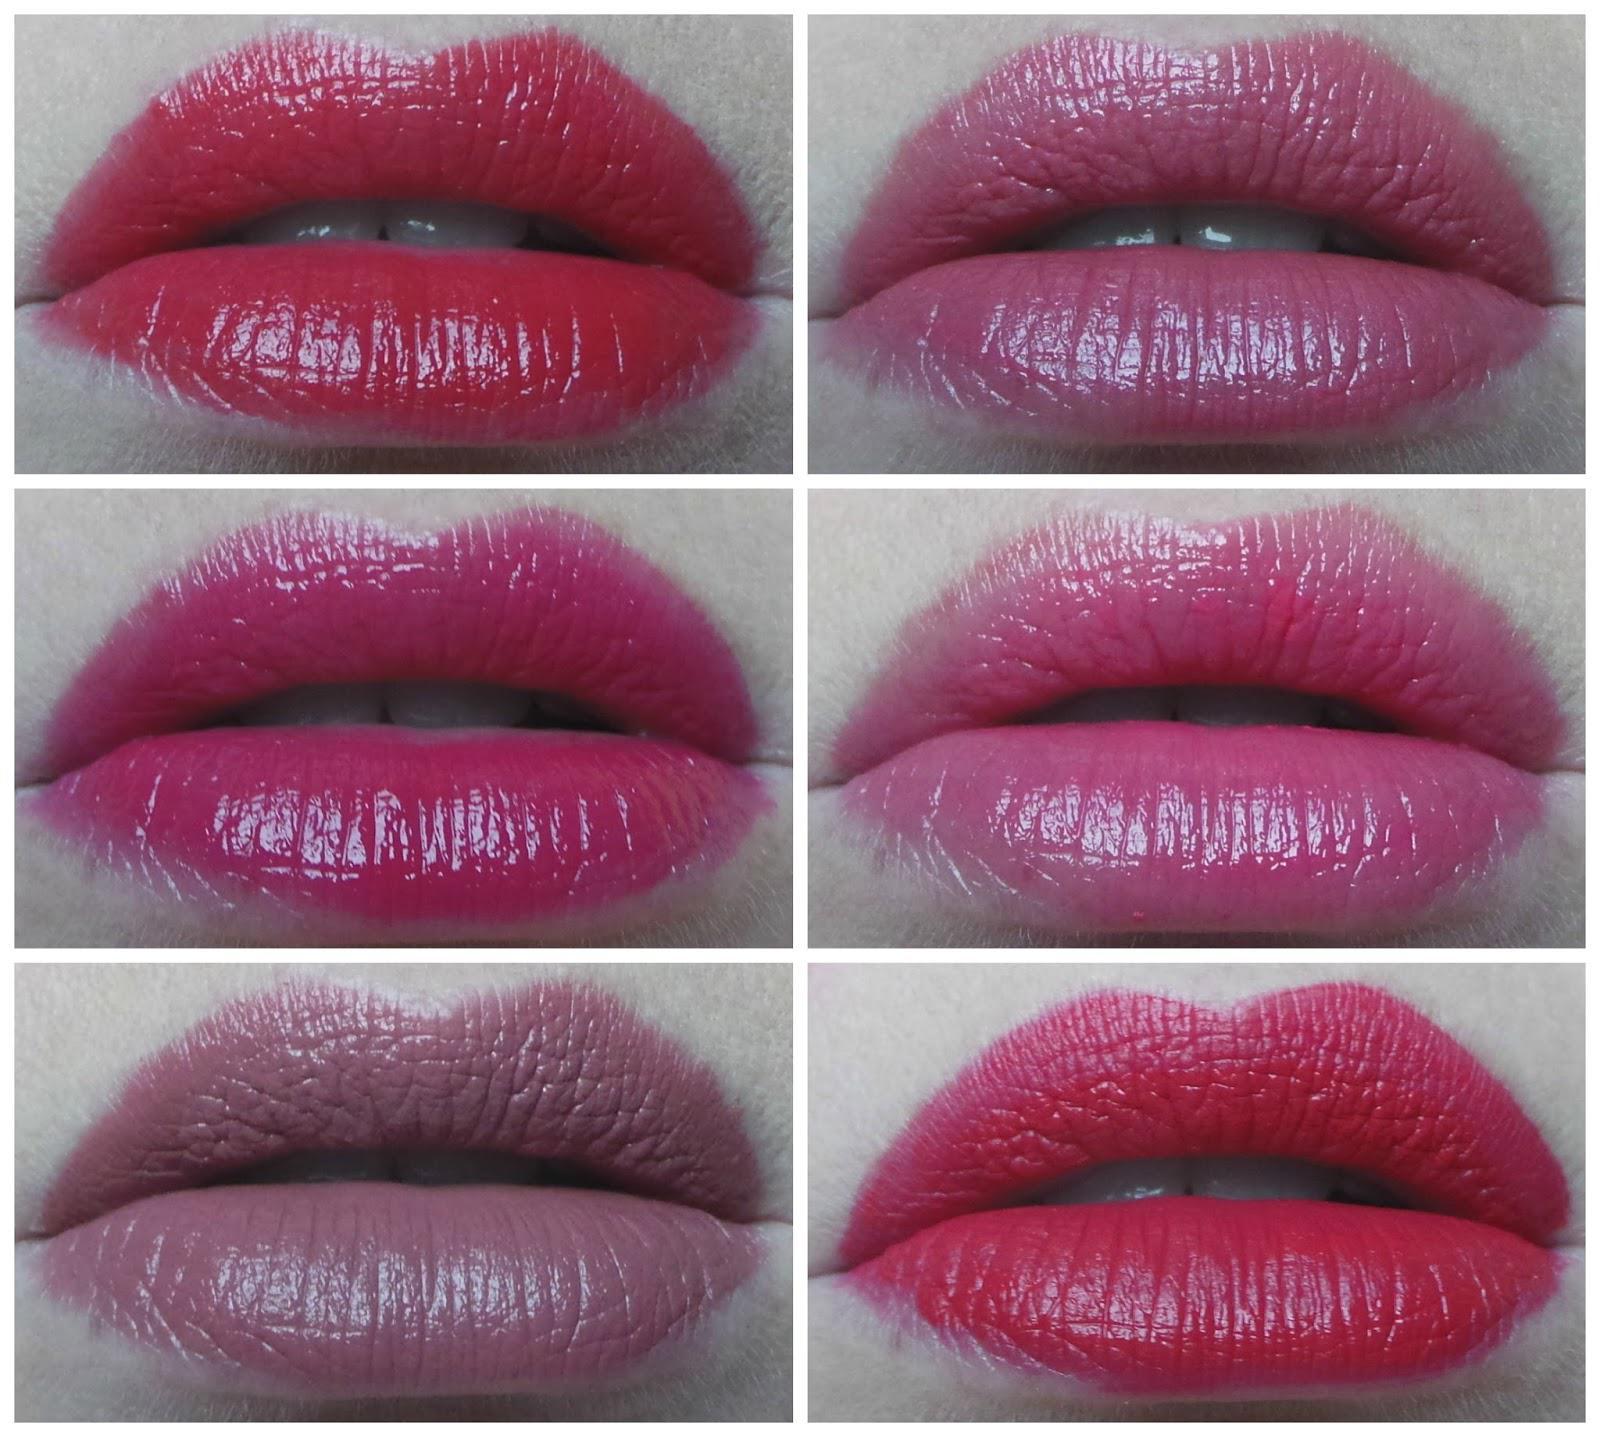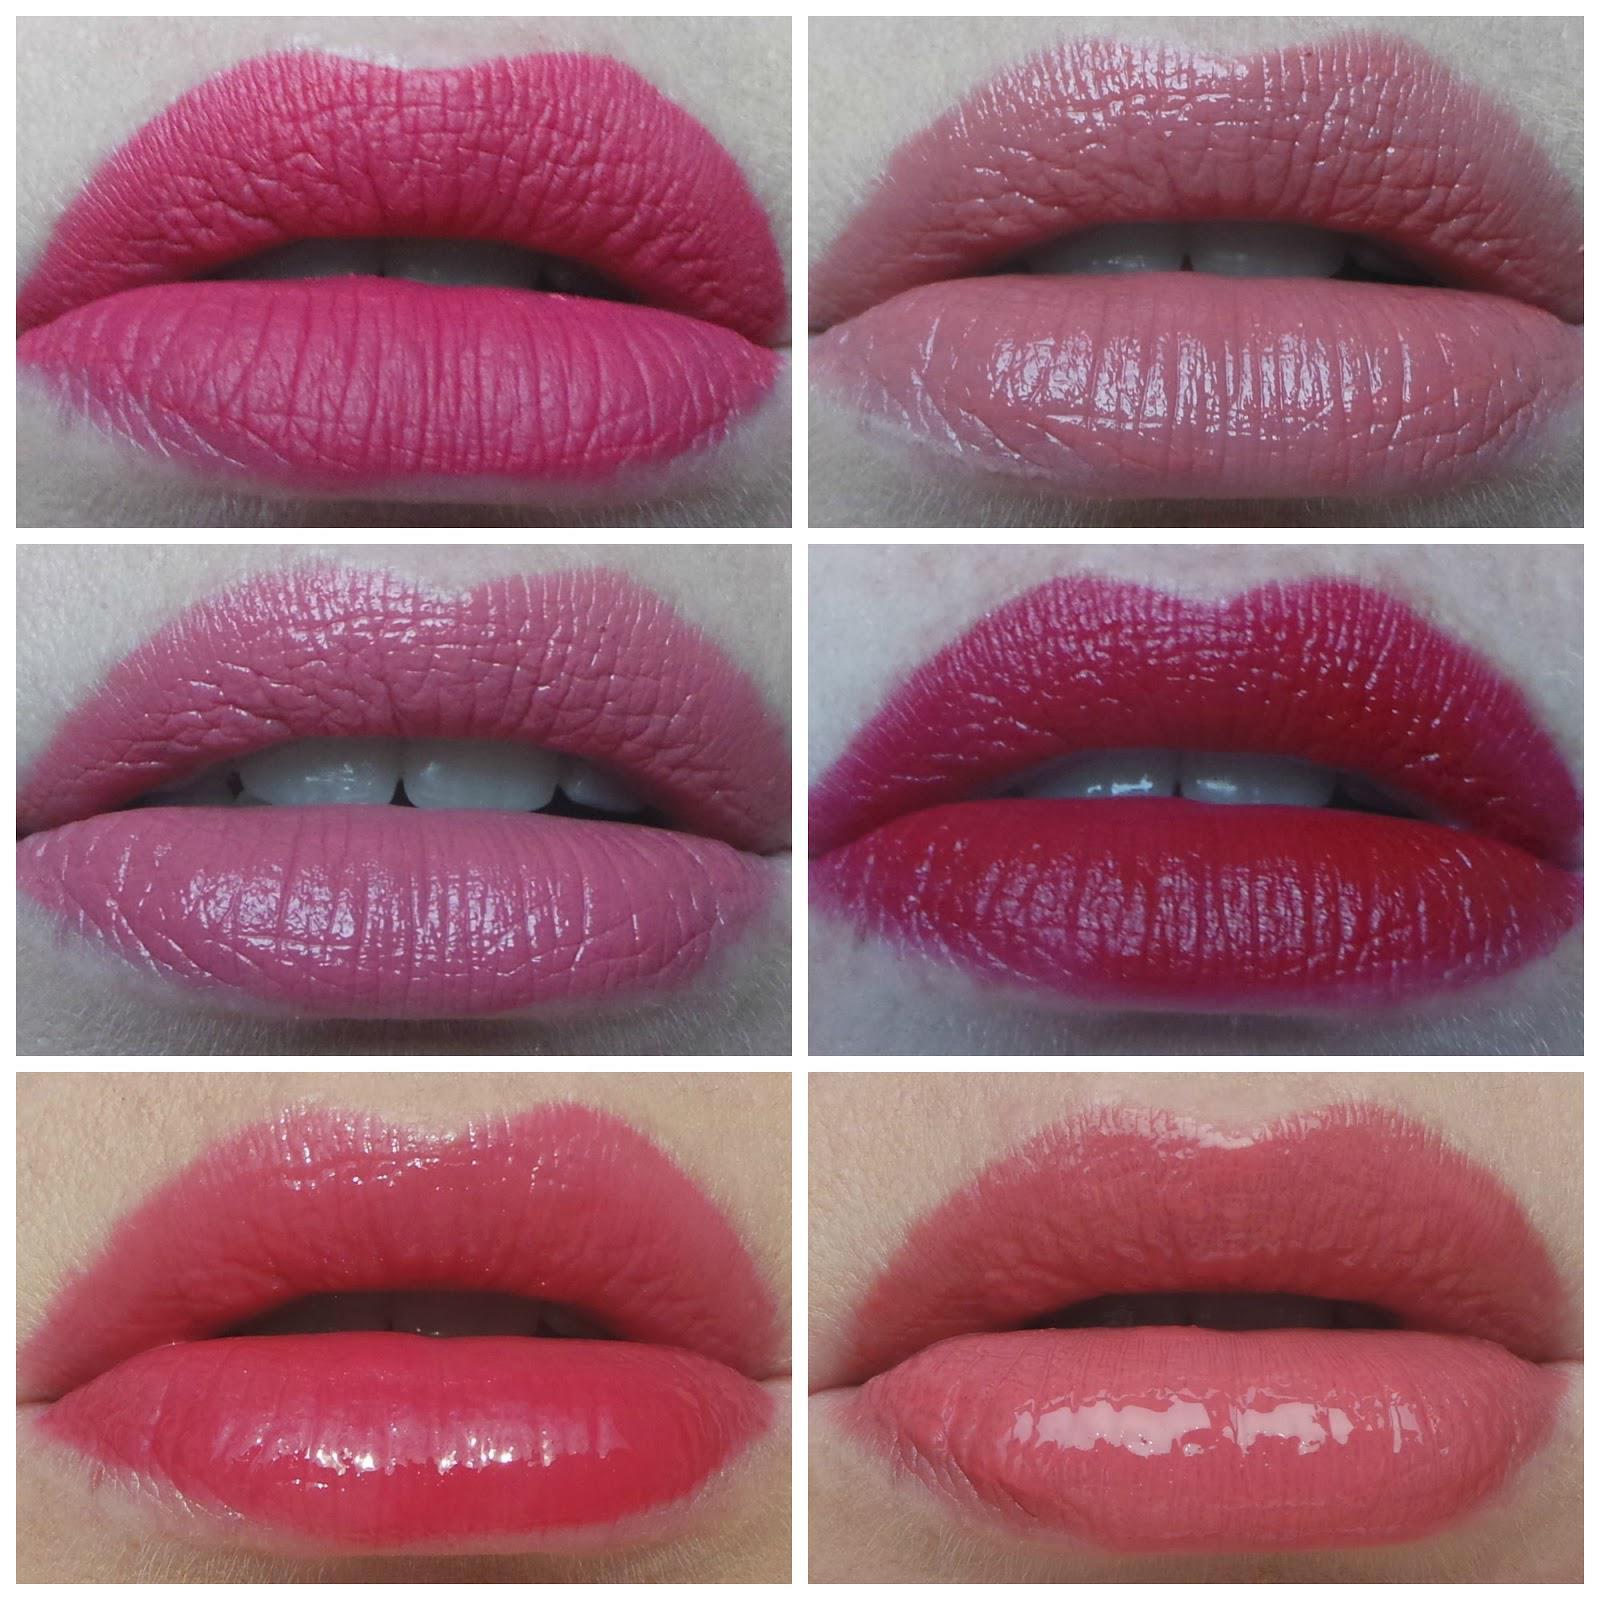The first image is the image on the left, the second image is the image on the right. Given the left and right images, does the statement "One picture shows six or more pigments of lipstick swatched on a human arm." hold true? Answer yes or no. No. 